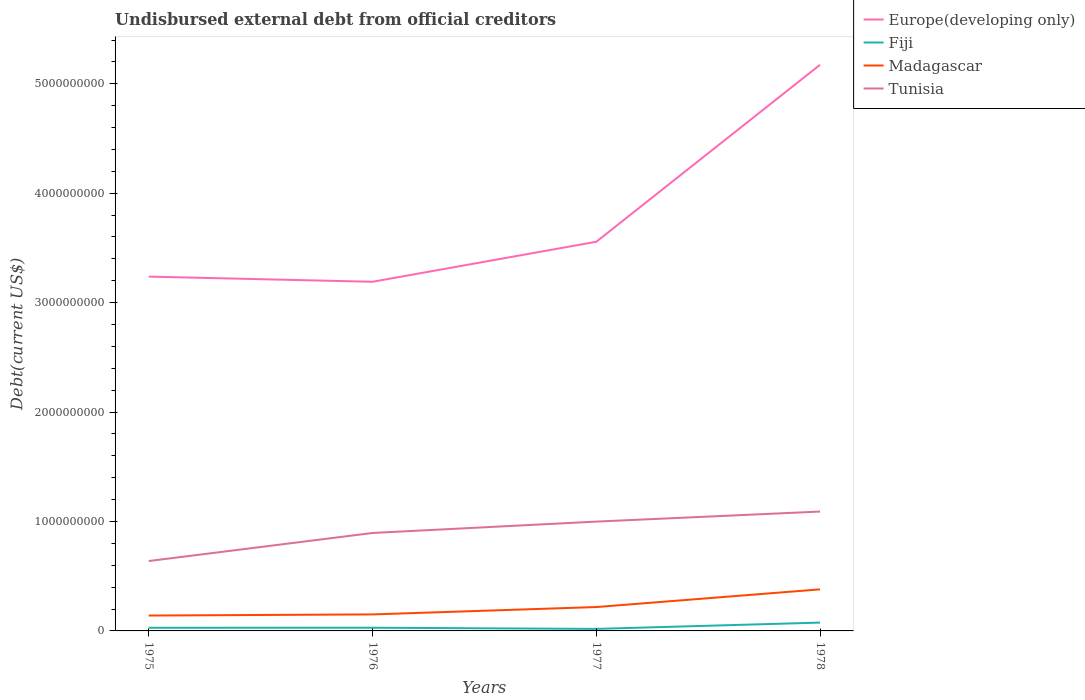Does the line corresponding to Fiji intersect with the line corresponding to Europe(developing only)?
Your answer should be compact. No. Is the number of lines equal to the number of legend labels?
Ensure brevity in your answer.  Yes. Across all years, what is the maximum total debt in Europe(developing only)?
Provide a succinct answer. 3.19e+09. In which year was the total debt in Tunisia maximum?
Your response must be concise. 1975. What is the total total debt in Fiji in the graph?
Ensure brevity in your answer.  -5.74e+07. What is the difference between the highest and the second highest total debt in Madagascar?
Your answer should be compact. 2.39e+08. What is the difference between the highest and the lowest total debt in Europe(developing only)?
Your response must be concise. 1. Is the total debt in Europe(developing only) strictly greater than the total debt in Madagascar over the years?
Provide a short and direct response. No. How many years are there in the graph?
Provide a succinct answer. 4. What is the difference between two consecutive major ticks on the Y-axis?
Offer a terse response. 1.00e+09. Are the values on the major ticks of Y-axis written in scientific E-notation?
Provide a succinct answer. No. Does the graph contain grids?
Ensure brevity in your answer.  No. What is the title of the graph?
Offer a terse response. Undisbursed external debt from official creditors. Does "San Marino" appear as one of the legend labels in the graph?
Offer a very short reply. No. What is the label or title of the X-axis?
Provide a succinct answer. Years. What is the label or title of the Y-axis?
Make the answer very short. Debt(current US$). What is the Debt(current US$) of Europe(developing only) in 1975?
Make the answer very short. 3.24e+09. What is the Debt(current US$) of Fiji in 1975?
Offer a terse response. 2.89e+07. What is the Debt(current US$) of Madagascar in 1975?
Your answer should be compact. 1.41e+08. What is the Debt(current US$) of Tunisia in 1975?
Make the answer very short. 6.39e+08. What is the Debt(current US$) of Europe(developing only) in 1976?
Offer a very short reply. 3.19e+09. What is the Debt(current US$) of Fiji in 1976?
Make the answer very short. 2.93e+07. What is the Debt(current US$) in Madagascar in 1976?
Give a very brief answer. 1.51e+08. What is the Debt(current US$) of Tunisia in 1976?
Give a very brief answer. 8.95e+08. What is the Debt(current US$) in Europe(developing only) in 1977?
Your answer should be very brief. 3.56e+09. What is the Debt(current US$) in Fiji in 1977?
Give a very brief answer. 1.86e+07. What is the Debt(current US$) in Madagascar in 1977?
Ensure brevity in your answer.  2.18e+08. What is the Debt(current US$) in Tunisia in 1977?
Provide a short and direct response. 9.99e+08. What is the Debt(current US$) of Europe(developing only) in 1978?
Your answer should be compact. 5.17e+09. What is the Debt(current US$) of Fiji in 1978?
Your answer should be compact. 7.61e+07. What is the Debt(current US$) in Madagascar in 1978?
Offer a terse response. 3.80e+08. What is the Debt(current US$) of Tunisia in 1978?
Make the answer very short. 1.09e+09. Across all years, what is the maximum Debt(current US$) of Europe(developing only)?
Provide a succinct answer. 5.17e+09. Across all years, what is the maximum Debt(current US$) in Fiji?
Your answer should be compact. 7.61e+07. Across all years, what is the maximum Debt(current US$) in Madagascar?
Provide a succinct answer. 3.80e+08. Across all years, what is the maximum Debt(current US$) of Tunisia?
Your response must be concise. 1.09e+09. Across all years, what is the minimum Debt(current US$) in Europe(developing only)?
Your answer should be compact. 3.19e+09. Across all years, what is the minimum Debt(current US$) of Fiji?
Your answer should be very brief. 1.86e+07. Across all years, what is the minimum Debt(current US$) of Madagascar?
Provide a succinct answer. 1.41e+08. Across all years, what is the minimum Debt(current US$) of Tunisia?
Ensure brevity in your answer.  6.39e+08. What is the total Debt(current US$) in Europe(developing only) in the graph?
Offer a terse response. 1.52e+1. What is the total Debt(current US$) in Fiji in the graph?
Your response must be concise. 1.53e+08. What is the total Debt(current US$) in Madagascar in the graph?
Make the answer very short. 8.90e+08. What is the total Debt(current US$) of Tunisia in the graph?
Your response must be concise. 3.62e+09. What is the difference between the Debt(current US$) in Europe(developing only) in 1975 and that in 1976?
Make the answer very short. 4.69e+07. What is the difference between the Debt(current US$) of Fiji in 1975 and that in 1976?
Your response must be concise. -3.98e+05. What is the difference between the Debt(current US$) in Madagascar in 1975 and that in 1976?
Your response must be concise. -1.03e+07. What is the difference between the Debt(current US$) in Tunisia in 1975 and that in 1976?
Offer a very short reply. -2.56e+08. What is the difference between the Debt(current US$) of Europe(developing only) in 1975 and that in 1977?
Keep it short and to the point. -3.19e+08. What is the difference between the Debt(current US$) in Fiji in 1975 and that in 1977?
Give a very brief answer. 1.02e+07. What is the difference between the Debt(current US$) in Madagascar in 1975 and that in 1977?
Provide a succinct answer. -7.76e+07. What is the difference between the Debt(current US$) in Tunisia in 1975 and that in 1977?
Keep it short and to the point. -3.60e+08. What is the difference between the Debt(current US$) in Europe(developing only) in 1975 and that in 1978?
Provide a succinct answer. -1.94e+09. What is the difference between the Debt(current US$) of Fiji in 1975 and that in 1978?
Offer a very short reply. -4.72e+07. What is the difference between the Debt(current US$) in Madagascar in 1975 and that in 1978?
Provide a succinct answer. -2.39e+08. What is the difference between the Debt(current US$) in Tunisia in 1975 and that in 1978?
Your response must be concise. -4.52e+08. What is the difference between the Debt(current US$) of Europe(developing only) in 1976 and that in 1977?
Your response must be concise. -3.66e+08. What is the difference between the Debt(current US$) in Fiji in 1976 and that in 1977?
Provide a succinct answer. 1.06e+07. What is the difference between the Debt(current US$) of Madagascar in 1976 and that in 1977?
Keep it short and to the point. -6.72e+07. What is the difference between the Debt(current US$) of Tunisia in 1976 and that in 1977?
Make the answer very short. -1.04e+08. What is the difference between the Debt(current US$) of Europe(developing only) in 1976 and that in 1978?
Offer a very short reply. -1.98e+09. What is the difference between the Debt(current US$) of Fiji in 1976 and that in 1978?
Provide a short and direct response. -4.68e+07. What is the difference between the Debt(current US$) in Madagascar in 1976 and that in 1978?
Keep it short and to the point. -2.29e+08. What is the difference between the Debt(current US$) of Tunisia in 1976 and that in 1978?
Offer a very short reply. -1.96e+08. What is the difference between the Debt(current US$) in Europe(developing only) in 1977 and that in 1978?
Give a very brief answer. -1.62e+09. What is the difference between the Debt(current US$) in Fiji in 1977 and that in 1978?
Your answer should be very brief. -5.74e+07. What is the difference between the Debt(current US$) of Madagascar in 1977 and that in 1978?
Ensure brevity in your answer.  -1.62e+08. What is the difference between the Debt(current US$) of Tunisia in 1977 and that in 1978?
Offer a very short reply. -9.19e+07. What is the difference between the Debt(current US$) in Europe(developing only) in 1975 and the Debt(current US$) in Fiji in 1976?
Provide a short and direct response. 3.21e+09. What is the difference between the Debt(current US$) of Europe(developing only) in 1975 and the Debt(current US$) of Madagascar in 1976?
Offer a very short reply. 3.09e+09. What is the difference between the Debt(current US$) of Europe(developing only) in 1975 and the Debt(current US$) of Tunisia in 1976?
Your answer should be very brief. 2.34e+09. What is the difference between the Debt(current US$) in Fiji in 1975 and the Debt(current US$) in Madagascar in 1976?
Your answer should be compact. -1.22e+08. What is the difference between the Debt(current US$) of Fiji in 1975 and the Debt(current US$) of Tunisia in 1976?
Offer a very short reply. -8.66e+08. What is the difference between the Debt(current US$) in Madagascar in 1975 and the Debt(current US$) in Tunisia in 1976?
Keep it short and to the point. -7.55e+08. What is the difference between the Debt(current US$) in Europe(developing only) in 1975 and the Debt(current US$) in Fiji in 1977?
Your answer should be compact. 3.22e+09. What is the difference between the Debt(current US$) in Europe(developing only) in 1975 and the Debt(current US$) in Madagascar in 1977?
Provide a succinct answer. 3.02e+09. What is the difference between the Debt(current US$) in Europe(developing only) in 1975 and the Debt(current US$) in Tunisia in 1977?
Provide a short and direct response. 2.24e+09. What is the difference between the Debt(current US$) of Fiji in 1975 and the Debt(current US$) of Madagascar in 1977?
Ensure brevity in your answer.  -1.89e+08. What is the difference between the Debt(current US$) in Fiji in 1975 and the Debt(current US$) in Tunisia in 1977?
Keep it short and to the point. -9.70e+08. What is the difference between the Debt(current US$) in Madagascar in 1975 and the Debt(current US$) in Tunisia in 1977?
Your answer should be very brief. -8.58e+08. What is the difference between the Debt(current US$) in Europe(developing only) in 1975 and the Debt(current US$) in Fiji in 1978?
Provide a succinct answer. 3.16e+09. What is the difference between the Debt(current US$) in Europe(developing only) in 1975 and the Debt(current US$) in Madagascar in 1978?
Keep it short and to the point. 2.86e+09. What is the difference between the Debt(current US$) of Europe(developing only) in 1975 and the Debt(current US$) of Tunisia in 1978?
Provide a short and direct response. 2.15e+09. What is the difference between the Debt(current US$) in Fiji in 1975 and the Debt(current US$) in Madagascar in 1978?
Keep it short and to the point. -3.51e+08. What is the difference between the Debt(current US$) in Fiji in 1975 and the Debt(current US$) in Tunisia in 1978?
Give a very brief answer. -1.06e+09. What is the difference between the Debt(current US$) of Madagascar in 1975 and the Debt(current US$) of Tunisia in 1978?
Provide a succinct answer. -9.50e+08. What is the difference between the Debt(current US$) in Europe(developing only) in 1976 and the Debt(current US$) in Fiji in 1977?
Ensure brevity in your answer.  3.17e+09. What is the difference between the Debt(current US$) of Europe(developing only) in 1976 and the Debt(current US$) of Madagascar in 1977?
Your answer should be compact. 2.97e+09. What is the difference between the Debt(current US$) in Europe(developing only) in 1976 and the Debt(current US$) in Tunisia in 1977?
Ensure brevity in your answer.  2.19e+09. What is the difference between the Debt(current US$) of Fiji in 1976 and the Debt(current US$) of Madagascar in 1977?
Offer a very short reply. -1.89e+08. What is the difference between the Debt(current US$) of Fiji in 1976 and the Debt(current US$) of Tunisia in 1977?
Offer a very short reply. -9.70e+08. What is the difference between the Debt(current US$) of Madagascar in 1976 and the Debt(current US$) of Tunisia in 1977?
Your response must be concise. -8.48e+08. What is the difference between the Debt(current US$) in Europe(developing only) in 1976 and the Debt(current US$) in Fiji in 1978?
Your answer should be very brief. 3.11e+09. What is the difference between the Debt(current US$) of Europe(developing only) in 1976 and the Debt(current US$) of Madagascar in 1978?
Make the answer very short. 2.81e+09. What is the difference between the Debt(current US$) in Europe(developing only) in 1976 and the Debt(current US$) in Tunisia in 1978?
Make the answer very short. 2.10e+09. What is the difference between the Debt(current US$) of Fiji in 1976 and the Debt(current US$) of Madagascar in 1978?
Your answer should be very brief. -3.51e+08. What is the difference between the Debt(current US$) in Fiji in 1976 and the Debt(current US$) in Tunisia in 1978?
Provide a succinct answer. -1.06e+09. What is the difference between the Debt(current US$) in Madagascar in 1976 and the Debt(current US$) in Tunisia in 1978?
Your answer should be very brief. -9.40e+08. What is the difference between the Debt(current US$) in Europe(developing only) in 1977 and the Debt(current US$) in Fiji in 1978?
Provide a short and direct response. 3.48e+09. What is the difference between the Debt(current US$) of Europe(developing only) in 1977 and the Debt(current US$) of Madagascar in 1978?
Make the answer very short. 3.18e+09. What is the difference between the Debt(current US$) in Europe(developing only) in 1977 and the Debt(current US$) in Tunisia in 1978?
Provide a succinct answer. 2.47e+09. What is the difference between the Debt(current US$) in Fiji in 1977 and the Debt(current US$) in Madagascar in 1978?
Your answer should be very brief. -3.61e+08. What is the difference between the Debt(current US$) of Fiji in 1977 and the Debt(current US$) of Tunisia in 1978?
Offer a terse response. -1.07e+09. What is the difference between the Debt(current US$) in Madagascar in 1977 and the Debt(current US$) in Tunisia in 1978?
Make the answer very short. -8.73e+08. What is the average Debt(current US$) of Europe(developing only) per year?
Your answer should be compact. 3.79e+09. What is the average Debt(current US$) in Fiji per year?
Give a very brief answer. 3.82e+07. What is the average Debt(current US$) in Madagascar per year?
Provide a short and direct response. 2.22e+08. What is the average Debt(current US$) in Tunisia per year?
Ensure brevity in your answer.  9.06e+08. In the year 1975, what is the difference between the Debt(current US$) in Europe(developing only) and Debt(current US$) in Fiji?
Your answer should be very brief. 3.21e+09. In the year 1975, what is the difference between the Debt(current US$) of Europe(developing only) and Debt(current US$) of Madagascar?
Your answer should be compact. 3.10e+09. In the year 1975, what is the difference between the Debt(current US$) of Europe(developing only) and Debt(current US$) of Tunisia?
Provide a succinct answer. 2.60e+09. In the year 1975, what is the difference between the Debt(current US$) in Fiji and Debt(current US$) in Madagascar?
Give a very brief answer. -1.12e+08. In the year 1975, what is the difference between the Debt(current US$) of Fiji and Debt(current US$) of Tunisia?
Offer a terse response. -6.10e+08. In the year 1975, what is the difference between the Debt(current US$) in Madagascar and Debt(current US$) in Tunisia?
Make the answer very short. -4.98e+08. In the year 1976, what is the difference between the Debt(current US$) of Europe(developing only) and Debt(current US$) of Fiji?
Keep it short and to the point. 3.16e+09. In the year 1976, what is the difference between the Debt(current US$) of Europe(developing only) and Debt(current US$) of Madagascar?
Make the answer very short. 3.04e+09. In the year 1976, what is the difference between the Debt(current US$) in Europe(developing only) and Debt(current US$) in Tunisia?
Your answer should be very brief. 2.30e+09. In the year 1976, what is the difference between the Debt(current US$) of Fiji and Debt(current US$) of Madagascar?
Offer a terse response. -1.22e+08. In the year 1976, what is the difference between the Debt(current US$) in Fiji and Debt(current US$) in Tunisia?
Provide a short and direct response. -8.66e+08. In the year 1976, what is the difference between the Debt(current US$) of Madagascar and Debt(current US$) of Tunisia?
Provide a succinct answer. -7.44e+08. In the year 1977, what is the difference between the Debt(current US$) of Europe(developing only) and Debt(current US$) of Fiji?
Your answer should be very brief. 3.54e+09. In the year 1977, what is the difference between the Debt(current US$) of Europe(developing only) and Debt(current US$) of Madagascar?
Provide a short and direct response. 3.34e+09. In the year 1977, what is the difference between the Debt(current US$) in Europe(developing only) and Debt(current US$) in Tunisia?
Give a very brief answer. 2.56e+09. In the year 1977, what is the difference between the Debt(current US$) of Fiji and Debt(current US$) of Madagascar?
Provide a succinct answer. -2.00e+08. In the year 1977, what is the difference between the Debt(current US$) of Fiji and Debt(current US$) of Tunisia?
Provide a short and direct response. -9.80e+08. In the year 1977, what is the difference between the Debt(current US$) of Madagascar and Debt(current US$) of Tunisia?
Provide a short and direct response. -7.81e+08. In the year 1978, what is the difference between the Debt(current US$) in Europe(developing only) and Debt(current US$) in Fiji?
Your response must be concise. 5.10e+09. In the year 1978, what is the difference between the Debt(current US$) in Europe(developing only) and Debt(current US$) in Madagascar?
Provide a short and direct response. 4.79e+09. In the year 1978, what is the difference between the Debt(current US$) in Europe(developing only) and Debt(current US$) in Tunisia?
Provide a succinct answer. 4.08e+09. In the year 1978, what is the difference between the Debt(current US$) in Fiji and Debt(current US$) in Madagascar?
Your answer should be very brief. -3.04e+08. In the year 1978, what is the difference between the Debt(current US$) in Fiji and Debt(current US$) in Tunisia?
Offer a very short reply. -1.01e+09. In the year 1978, what is the difference between the Debt(current US$) of Madagascar and Debt(current US$) of Tunisia?
Your answer should be very brief. -7.11e+08. What is the ratio of the Debt(current US$) of Europe(developing only) in 1975 to that in 1976?
Your answer should be very brief. 1.01. What is the ratio of the Debt(current US$) of Fiji in 1975 to that in 1976?
Your response must be concise. 0.99. What is the ratio of the Debt(current US$) of Madagascar in 1975 to that in 1976?
Make the answer very short. 0.93. What is the ratio of the Debt(current US$) of Tunisia in 1975 to that in 1976?
Provide a short and direct response. 0.71. What is the ratio of the Debt(current US$) in Europe(developing only) in 1975 to that in 1977?
Make the answer very short. 0.91. What is the ratio of the Debt(current US$) of Fiji in 1975 to that in 1977?
Make the answer very short. 1.55. What is the ratio of the Debt(current US$) in Madagascar in 1975 to that in 1977?
Your answer should be compact. 0.64. What is the ratio of the Debt(current US$) in Tunisia in 1975 to that in 1977?
Ensure brevity in your answer.  0.64. What is the ratio of the Debt(current US$) of Europe(developing only) in 1975 to that in 1978?
Give a very brief answer. 0.63. What is the ratio of the Debt(current US$) in Fiji in 1975 to that in 1978?
Give a very brief answer. 0.38. What is the ratio of the Debt(current US$) of Madagascar in 1975 to that in 1978?
Give a very brief answer. 0.37. What is the ratio of the Debt(current US$) of Tunisia in 1975 to that in 1978?
Keep it short and to the point. 0.59. What is the ratio of the Debt(current US$) of Europe(developing only) in 1976 to that in 1977?
Provide a succinct answer. 0.9. What is the ratio of the Debt(current US$) in Fiji in 1976 to that in 1977?
Your answer should be very brief. 1.57. What is the ratio of the Debt(current US$) of Madagascar in 1976 to that in 1977?
Give a very brief answer. 0.69. What is the ratio of the Debt(current US$) in Tunisia in 1976 to that in 1977?
Give a very brief answer. 0.9. What is the ratio of the Debt(current US$) in Europe(developing only) in 1976 to that in 1978?
Keep it short and to the point. 0.62. What is the ratio of the Debt(current US$) in Fiji in 1976 to that in 1978?
Ensure brevity in your answer.  0.38. What is the ratio of the Debt(current US$) in Madagascar in 1976 to that in 1978?
Ensure brevity in your answer.  0.4. What is the ratio of the Debt(current US$) in Tunisia in 1976 to that in 1978?
Ensure brevity in your answer.  0.82. What is the ratio of the Debt(current US$) of Europe(developing only) in 1977 to that in 1978?
Ensure brevity in your answer.  0.69. What is the ratio of the Debt(current US$) in Fiji in 1977 to that in 1978?
Ensure brevity in your answer.  0.24. What is the ratio of the Debt(current US$) of Madagascar in 1977 to that in 1978?
Your answer should be very brief. 0.57. What is the ratio of the Debt(current US$) of Tunisia in 1977 to that in 1978?
Your answer should be compact. 0.92. What is the difference between the highest and the second highest Debt(current US$) of Europe(developing only)?
Your answer should be very brief. 1.62e+09. What is the difference between the highest and the second highest Debt(current US$) of Fiji?
Your response must be concise. 4.68e+07. What is the difference between the highest and the second highest Debt(current US$) of Madagascar?
Ensure brevity in your answer.  1.62e+08. What is the difference between the highest and the second highest Debt(current US$) of Tunisia?
Make the answer very short. 9.19e+07. What is the difference between the highest and the lowest Debt(current US$) in Europe(developing only)?
Keep it short and to the point. 1.98e+09. What is the difference between the highest and the lowest Debt(current US$) of Fiji?
Provide a short and direct response. 5.74e+07. What is the difference between the highest and the lowest Debt(current US$) in Madagascar?
Ensure brevity in your answer.  2.39e+08. What is the difference between the highest and the lowest Debt(current US$) of Tunisia?
Your response must be concise. 4.52e+08. 